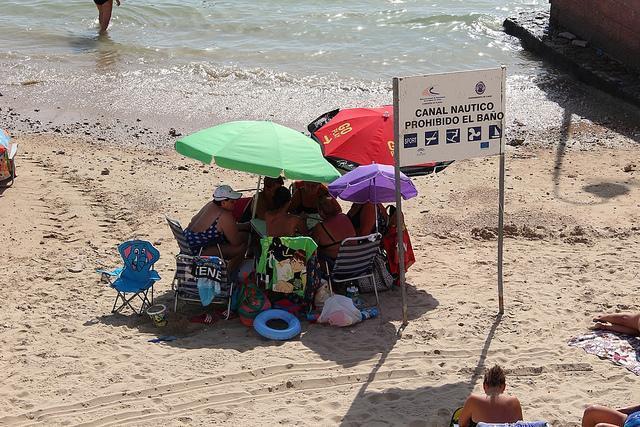How many umbrellas are in the picture?
Give a very brief answer. 3. How many chairs are visible?
Give a very brief answer. 3. 